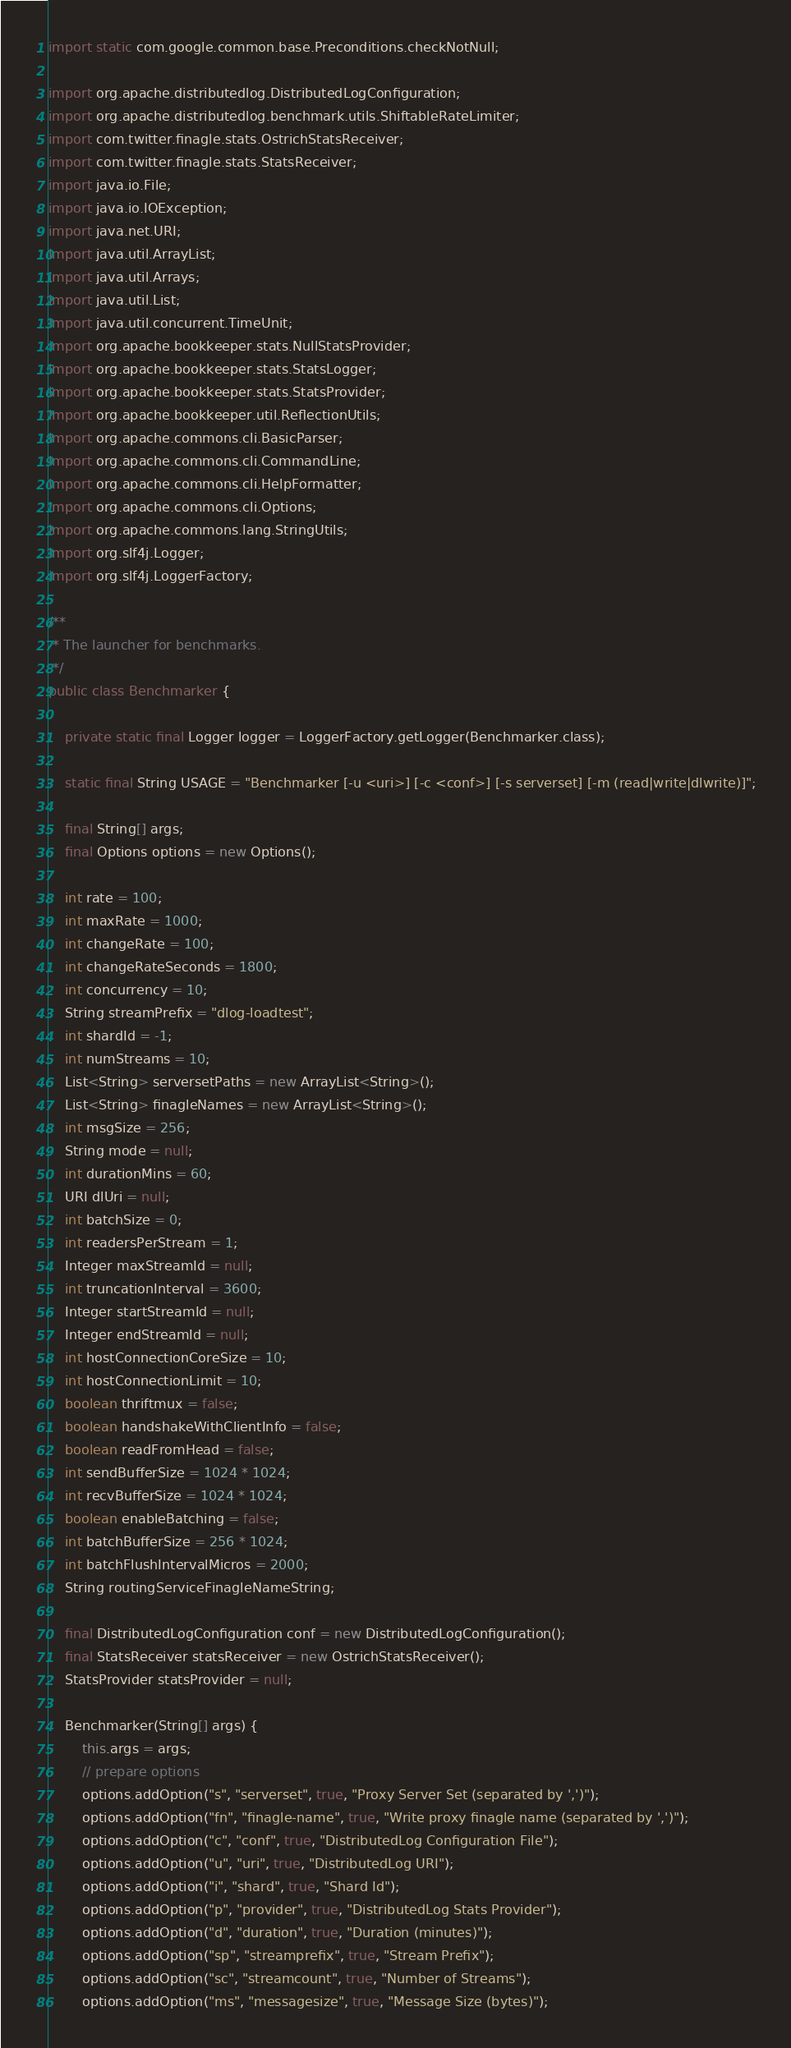<code> <loc_0><loc_0><loc_500><loc_500><_Java_>import static com.google.common.base.Preconditions.checkNotNull;

import org.apache.distributedlog.DistributedLogConfiguration;
import org.apache.distributedlog.benchmark.utils.ShiftableRateLimiter;
import com.twitter.finagle.stats.OstrichStatsReceiver;
import com.twitter.finagle.stats.StatsReceiver;
import java.io.File;
import java.io.IOException;
import java.net.URI;
import java.util.ArrayList;
import java.util.Arrays;
import java.util.List;
import java.util.concurrent.TimeUnit;
import org.apache.bookkeeper.stats.NullStatsProvider;
import org.apache.bookkeeper.stats.StatsLogger;
import org.apache.bookkeeper.stats.StatsProvider;
import org.apache.bookkeeper.util.ReflectionUtils;
import org.apache.commons.cli.BasicParser;
import org.apache.commons.cli.CommandLine;
import org.apache.commons.cli.HelpFormatter;
import org.apache.commons.cli.Options;
import org.apache.commons.lang.StringUtils;
import org.slf4j.Logger;
import org.slf4j.LoggerFactory;

/**
 * The launcher for benchmarks.
 */
public class Benchmarker {

    private static final Logger logger = LoggerFactory.getLogger(Benchmarker.class);

    static final String USAGE = "Benchmarker [-u <uri>] [-c <conf>] [-s serverset] [-m (read|write|dlwrite)]";

    final String[] args;
    final Options options = new Options();

    int rate = 100;
    int maxRate = 1000;
    int changeRate = 100;
    int changeRateSeconds = 1800;
    int concurrency = 10;
    String streamPrefix = "dlog-loadtest";
    int shardId = -1;
    int numStreams = 10;
    List<String> serversetPaths = new ArrayList<String>();
    List<String> finagleNames = new ArrayList<String>();
    int msgSize = 256;
    String mode = null;
    int durationMins = 60;
    URI dlUri = null;
    int batchSize = 0;
    int readersPerStream = 1;
    Integer maxStreamId = null;
    int truncationInterval = 3600;
    Integer startStreamId = null;
    Integer endStreamId = null;
    int hostConnectionCoreSize = 10;
    int hostConnectionLimit = 10;
    boolean thriftmux = false;
    boolean handshakeWithClientInfo = false;
    boolean readFromHead = false;
    int sendBufferSize = 1024 * 1024;
    int recvBufferSize = 1024 * 1024;
    boolean enableBatching = false;
    int batchBufferSize = 256 * 1024;
    int batchFlushIntervalMicros = 2000;
    String routingServiceFinagleNameString;

    final DistributedLogConfiguration conf = new DistributedLogConfiguration();
    final StatsReceiver statsReceiver = new OstrichStatsReceiver();
    StatsProvider statsProvider = null;

    Benchmarker(String[] args) {
        this.args = args;
        // prepare options
        options.addOption("s", "serverset", true, "Proxy Server Set (separated by ',')");
        options.addOption("fn", "finagle-name", true, "Write proxy finagle name (separated by ',')");
        options.addOption("c", "conf", true, "DistributedLog Configuration File");
        options.addOption("u", "uri", true, "DistributedLog URI");
        options.addOption("i", "shard", true, "Shard Id");
        options.addOption("p", "provider", true, "DistributedLog Stats Provider");
        options.addOption("d", "duration", true, "Duration (minutes)");
        options.addOption("sp", "streamprefix", true, "Stream Prefix");
        options.addOption("sc", "streamcount", true, "Number of Streams");
        options.addOption("ms", "messagesize", true, "Message Size (bytes)");</code> 